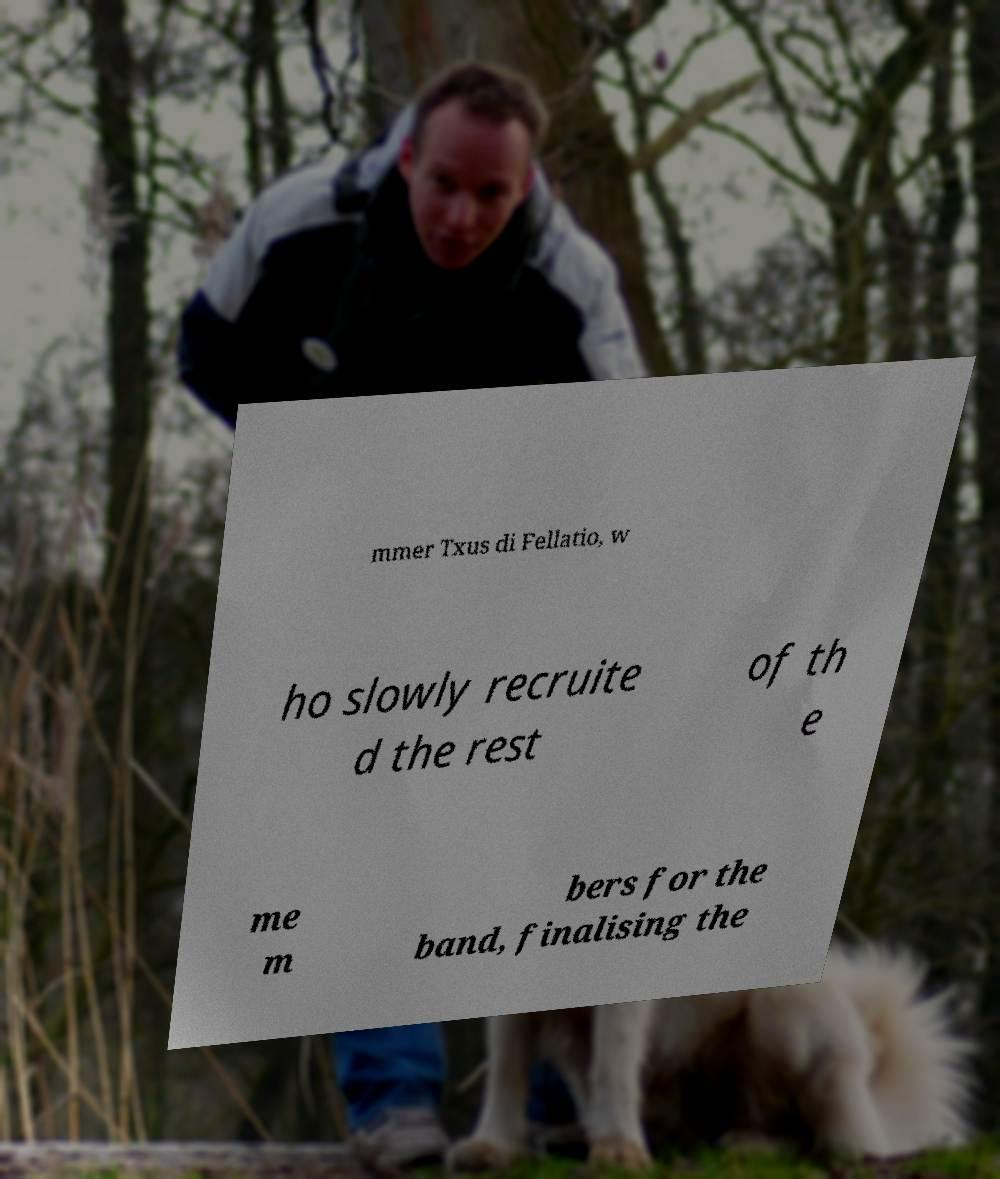Please identify and transcribe the text found in this image. mmer Txus di Fellatio, w ho slowly recruite d the rest of th e me m bers for the band, finalising the 